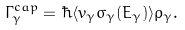<formula> <loc_0><loc_0><loc_500><loc_500>\Gamma _ { \gamma } ^ { c a p } = \hbar { \langle } v _ { \gamma } \sigma _ { \gamma } ( E _ { \gamma } ) \rangle \rho _ { \gamma } .</formula> 